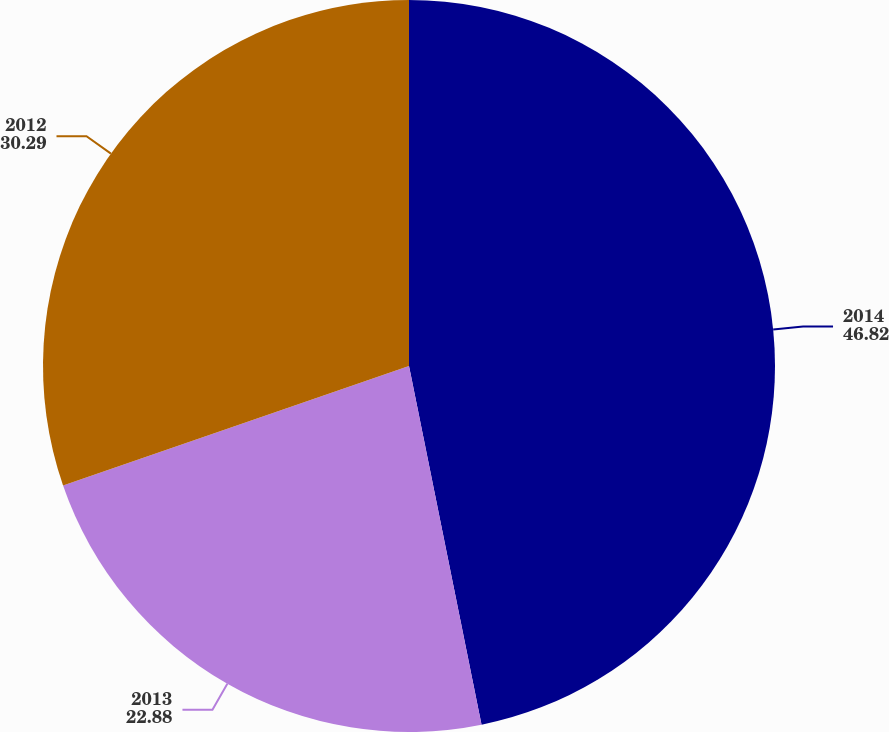Convert chart. <chart><loc_0><loc_0><loc_500><loc_500><pie_chart><fcel>2014<fcel>2013<fcel>2012<nl><fcel>46.82%<fcel>22.88%<fcel>30.29%<nl></chart> 